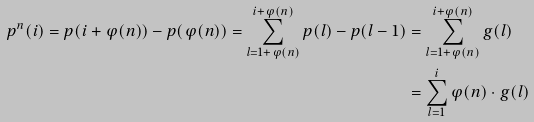Convert formula to latex. <formula><loc_0><loc_0><loc_500><loc_500>p ^ { n } ( i ) = p ( i + \varphi ( n ) ) - p ( \varphi ( n ) ) = \sum _ { l = 1 + \varphi ( n ) } ^ { i + \varphi ( n ) } p ( l ) - p ( l - 1 ) & = \sum _ { l = 1 + \varphi ( n ) } ^ { i + \varphi ( n ) } g ( l ) \\ & = \sum _ { l = 1 } ^ { i } \varphi ( n ) \cdot g ( l )</formula> 